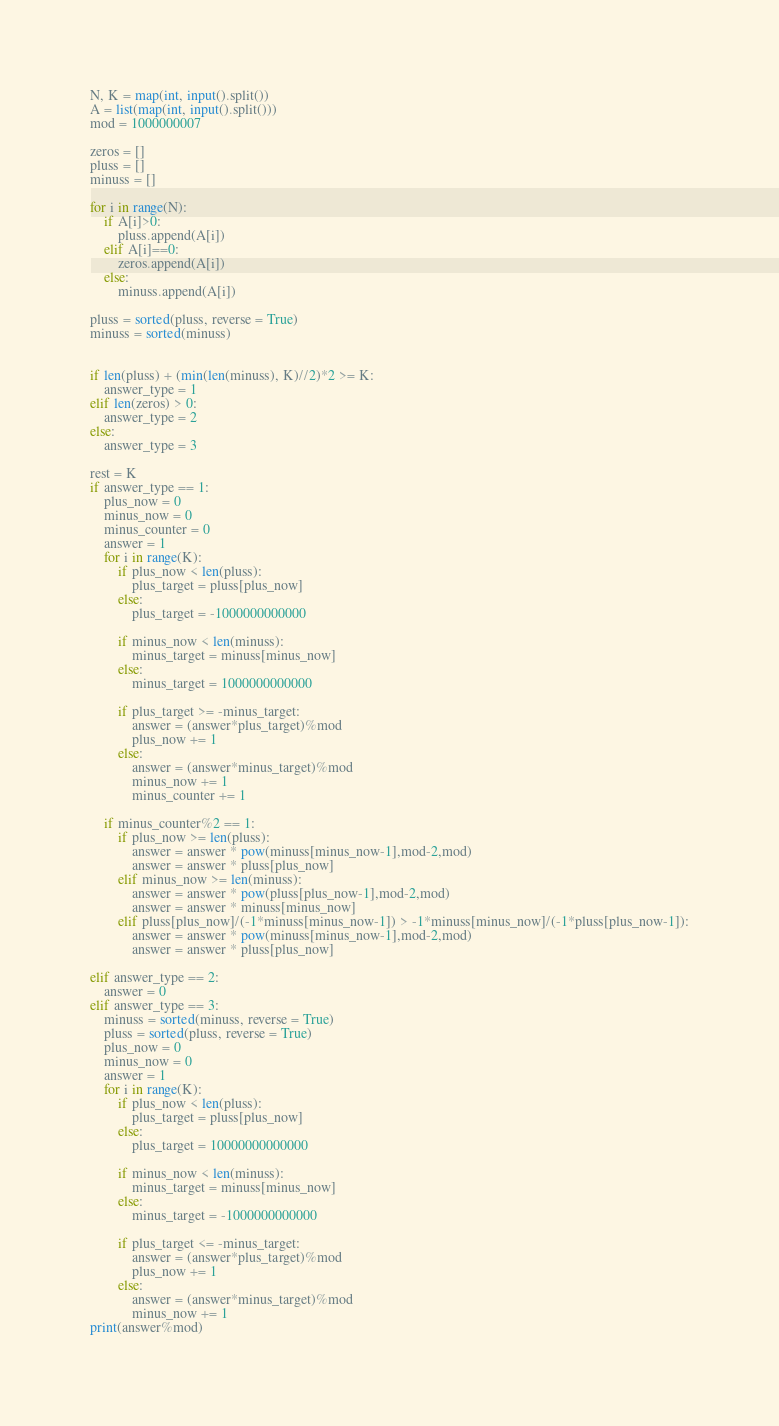Convert code to text. <code><loc_0><loc_0><loc_500><loc_500><_Python_>N, K = map(int, input().split())
A = list(map(int, input().split()))
mod = 1000000007

zeros = []
pluss = []
minuss = []

for i in range(N):
    if A[i]>0:
        pluss.append(A[i])
    elif A[i]==0:
        zeros.append(A[i])
    else:
        minuss.append(A[i])

pluss = sorted(pluss, reverse = True)
minuss = sorted(minuss)


if len(pluss) + (min(len(minuss), K)//2)*2 >= K:
    answer_type = 1
elif len(zeros) > 0:
    answer_type = 2
else:
    answer_type = 3

rest = K
if answer_type == 1:
    plus_now = 0
    minus_now = 0
    minus_counter = 0
    answer = 1
    for i in range(K):
        if plus_now < len(pluss):
            plus_target = pluss[plus_now]
        else:
            plus_target = -1000000000000
        
        if minus_now < len(minuss):
            minus_target = minuss[minus_now]
        else:
            minus_target = 1000000000000
        
        if plus_target >= -minus_target:
            answer = (answer*plus_target)%mod
            plus_now += 1
        else:
            answer = (answer*minus_target)%mod
            minus_now += 1
            minus_counter += 1
    
    if minus_counter%2 == 1:
        if plus_now >= len(pluss):
            answer = answer * pow(minuss[minus_now-1],mod-2,mod)
            answer = answer * pluss[plus_now]
        elif minus_now >= len(minuss):
            answer = answer * pow(pluss[plus_now-1],mod-2,mod)
            answer = answer * minuss[minus_now]
        elif pluss[plus_now]/(-1*minuss[minus_now-1]) > -1*minuss[minus_now]/(-1*pluss[plus_now-1]):
            answer = answer * pow(minuss[minus_now-1],mod-2,mod)
            answer = answer * pluss[plus_now]

elif answer_type == 2:
    answer = 0
elif answer_type == 3:
    minuss = sorted(minuss, reverse = True)
    pluss = sorted(pluss, reverse = True)
    plus_now = 0
    minus_now = 0
    answer = 1
    for i in range(K):
        if plus_now < len(pluss):
            plus_target = pluss[plus_now]
        else:
            plus_target = 10000000000000
        
        if minus_now < len(minuss):
            minus_target = minuss[minus_now]
        else:
            minus_target = -1000000000000  
        
        if plus_target <= -minus_target:
            answer = (answer*plus_target)%mod
            plus_now += 1
        else:
            answer = (answer*minus_target)%mod
            minus_now += 1
print(answer%mod)</code> 